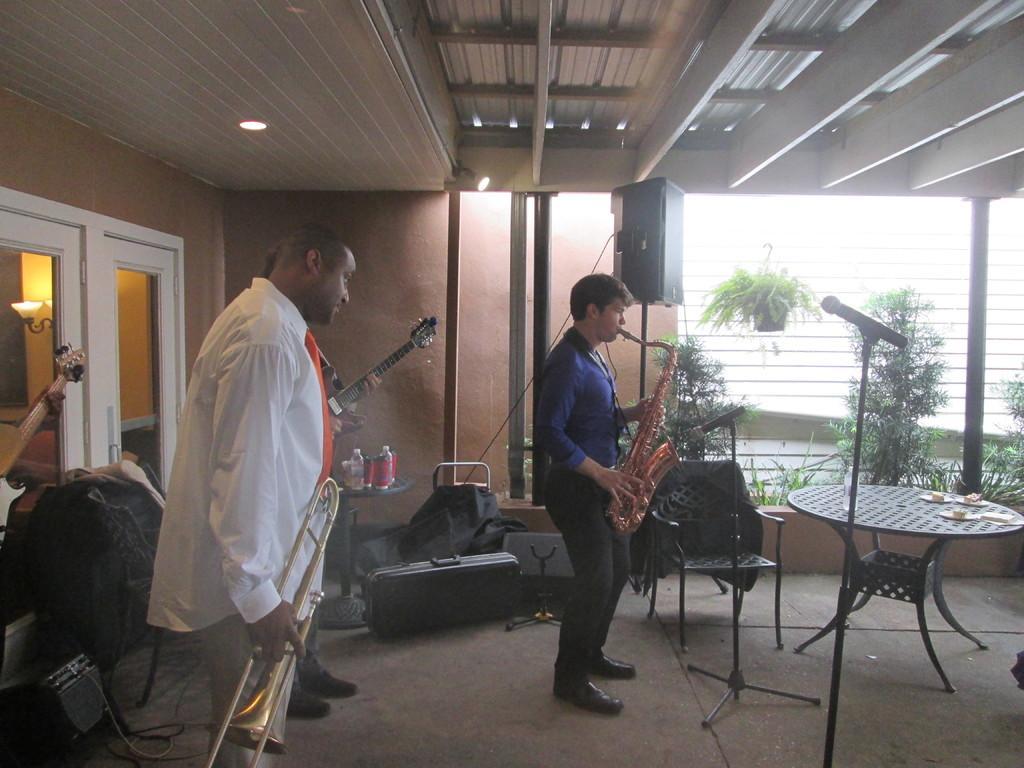How would you summarize this image in a sentence or two? In this image, we can see people and are holding musical instruments and we can see some stands, chairs, lights, some bottles and there are clothes. In the background, there are trees. At the bottom, there is a floor and at the top, there is a roof. 